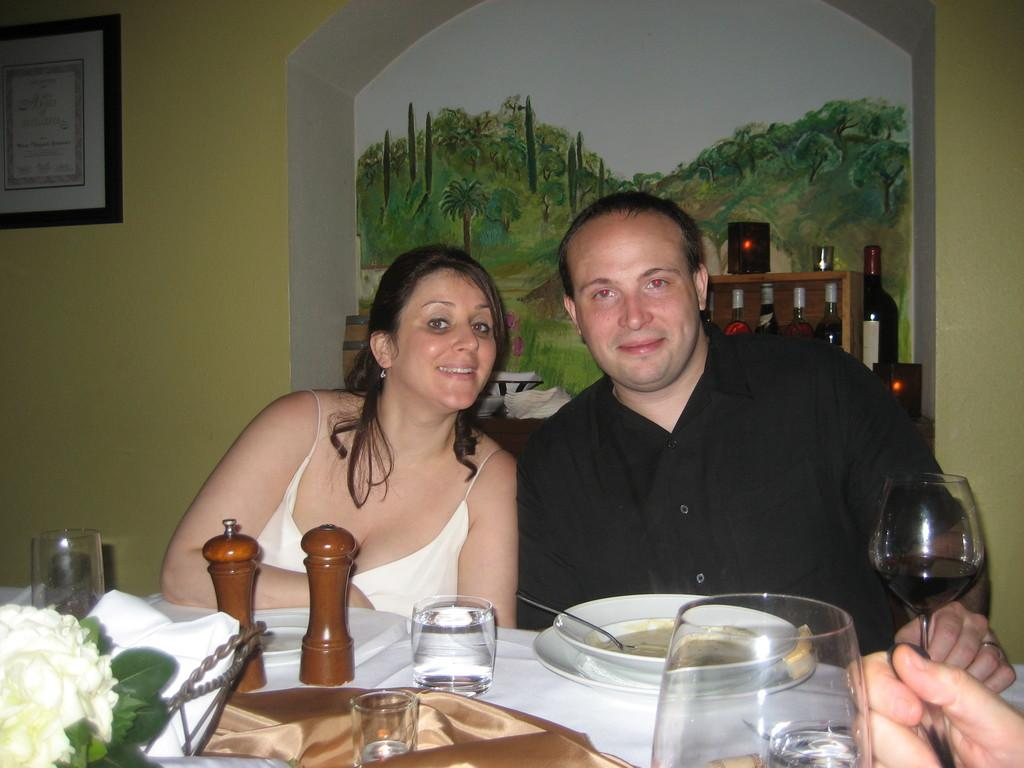How many people are present in the image? There are two persons sitting in the image. What can be seen in the background of the image? There is a wall and a frame in the background of the image. What is on the table in the image? There is a table in the image with a glass, a plate, a bowl, a spoon, food, a cloth, a flower, and a paper on it. Are there any other items on the table? Yes, there are other things on the table. What type of skirt is the spoon wearing in the image? There is no skirt or spoon wearing a skirt present in the image. What show is being performed on the table in the image? There is no show being performed on the table in the image. 